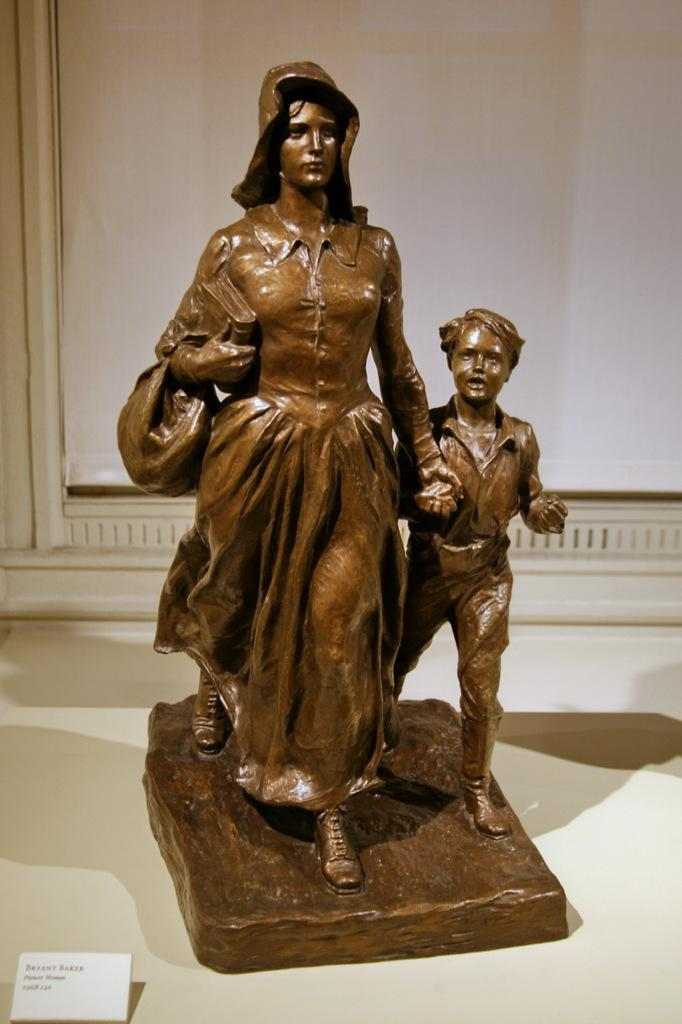What is the main subject in the image? There is a statue in the image. What is the color of the surface on which the statue is placed? The statue is on a white surface. Is there any additional information provided about the statue? Yes, there is an information card in front of the statue. What can be seen in the background of the image? There is a board in the background of the image. What type of sign is the statue holding in the image? There is no sign present in the image; the statue is not holding anything. 